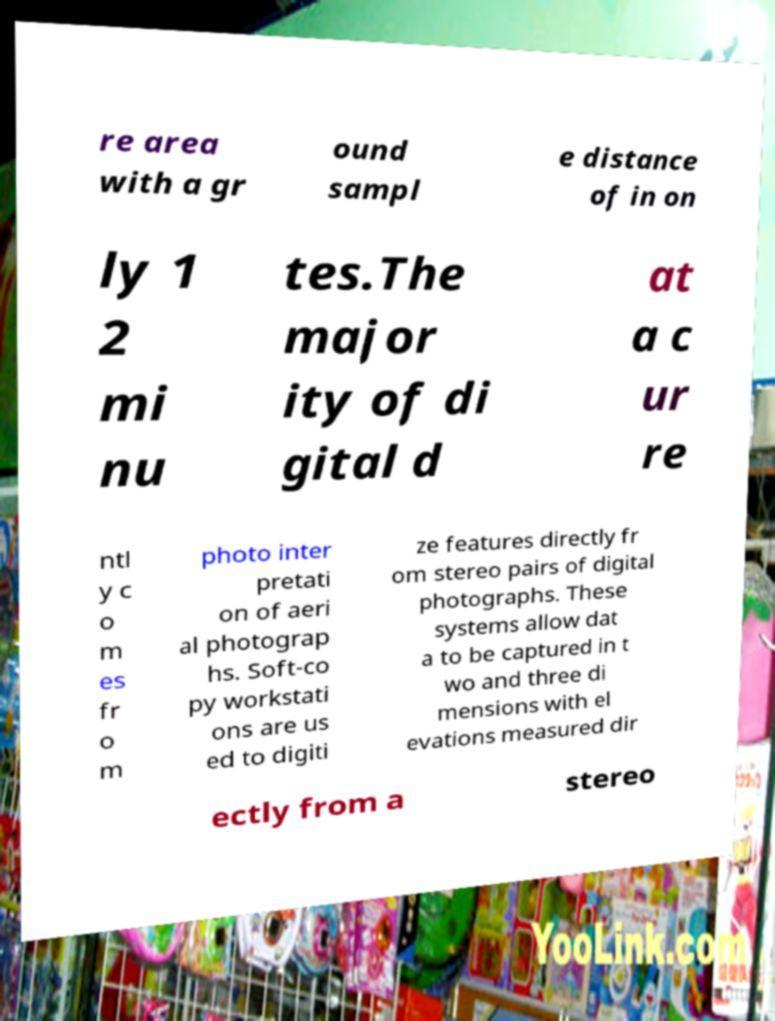Can you read and provide the text displayed in the image?This photo seems to have some interesting text. Can you extract and type it out for me? re area with a gr ound sampl e distance of in on ly 1 2 mi nu tes.The major ity of di gital d at a c ur re ntl y c o m es fr o m photo inter pretati on of aeri al photograp hs. Soft-co py workstati ons are us ed to digiti ze features directly fr om stereo pairs of digital photographs. These systems allow dat a to be captured in t wo and three di mensions with el evations measured dir ectly from a stereo 